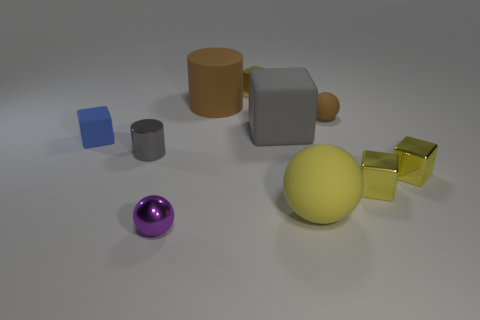There is a large rubber thing that is the same color as the small matte sphere; what shape is it?
Provide a succinct answer. Cylinder. How many small shiny things have the same color as the big rubber block?
Provide a short and direct response. 1. There is a cylinder that is the same size as the purple ball; what material is it?
Provide a succinct answer. Metal. Does the big thing that is in front of the gray metal object have the same material as the tiny blue block?
Make the answer very short. Yes. The thing that is both behind the big gray matte block and on the right side of the large sphere is what color?
Your answer should be very brief. Brown. How many yellow metal blocks are on the left side of the rubber ball in front of the large block?
Offer a very short reply. 1. What material is the yellow object that is the same shape as the small brown object?
Ensure brevity in your answer.  Rubber. What color is the small matte ball?
Provide a short and direct response. Brown. How many objects are either large gray metal blocks or brown matte objects?
Provide a short and direct response. 2. There is a small metal object behind the small ball on the right side of the large yellow rubber ball; what is its shape?
Provide a short and direct response. Cube. 